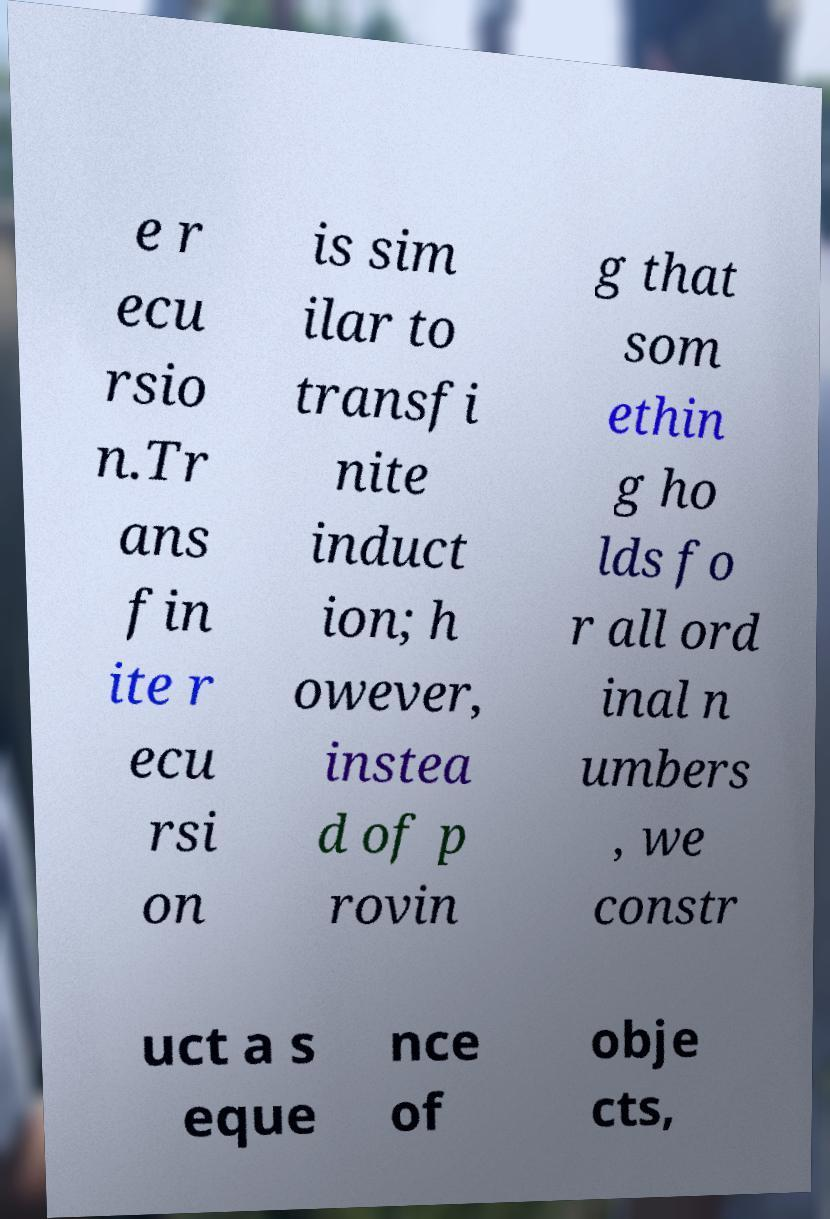For documentation purposes, I need the text within this image transcribed. Could you provide that? e r ecu rsio n.Tr ans fin ite r ecu rsi on is sim ilar to transfi nite induct ion; h owever, instea d of p rovin g that som ethin g ho lds fo r all ord inal n umbers , we constr uct a s eque nce of obje cts, 